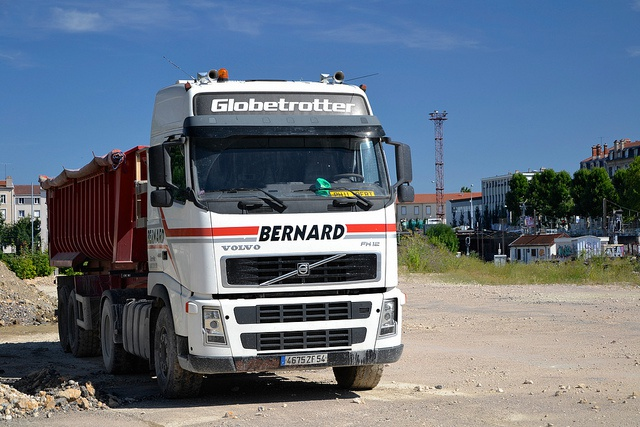Describe the objects in this image and their specific colors. I can see truck in gray, black, white, and darkgray tones, truck in gray, darkgray, black, and darkgreen tones, and traffic light in gray, black, maroon, and red tones in this image. 